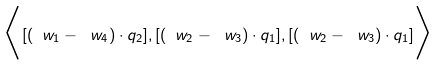Convert formula to latex. <formula><loc_0><loc_0><loc_500><loc_500>\Big { \langle } [ ( \ w _ { 1 } - \ w _ { 4 } ) \cdot q _ { 2 } ] , [ ( \ w _ { 2 } - \ w _ { 3 } ) \cdot q _ { 1 } ] , [ ( \ w _ { 2 } - \ w _ { 3 } ) \cdot q _ { 1 } ] \Big { \rangle }</formula> 